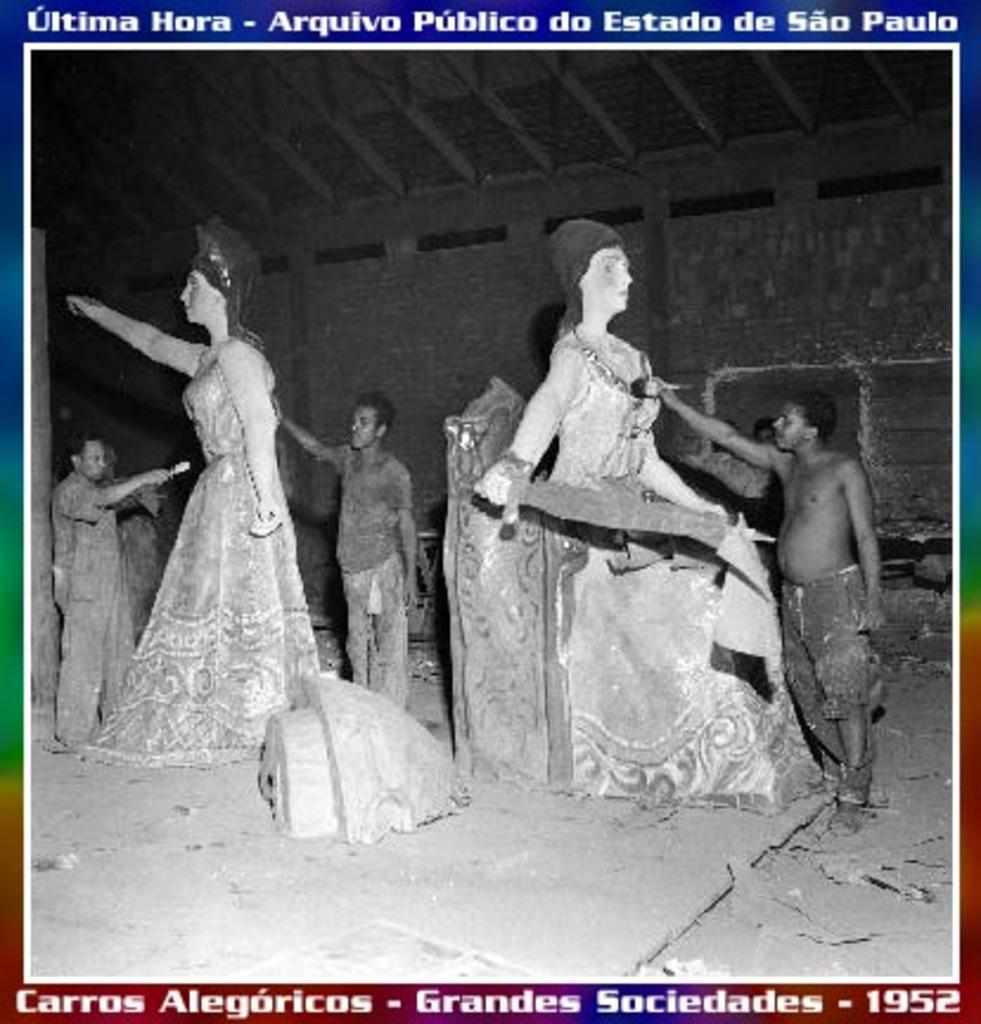What year was this?
Your response must be concise. 1952. 